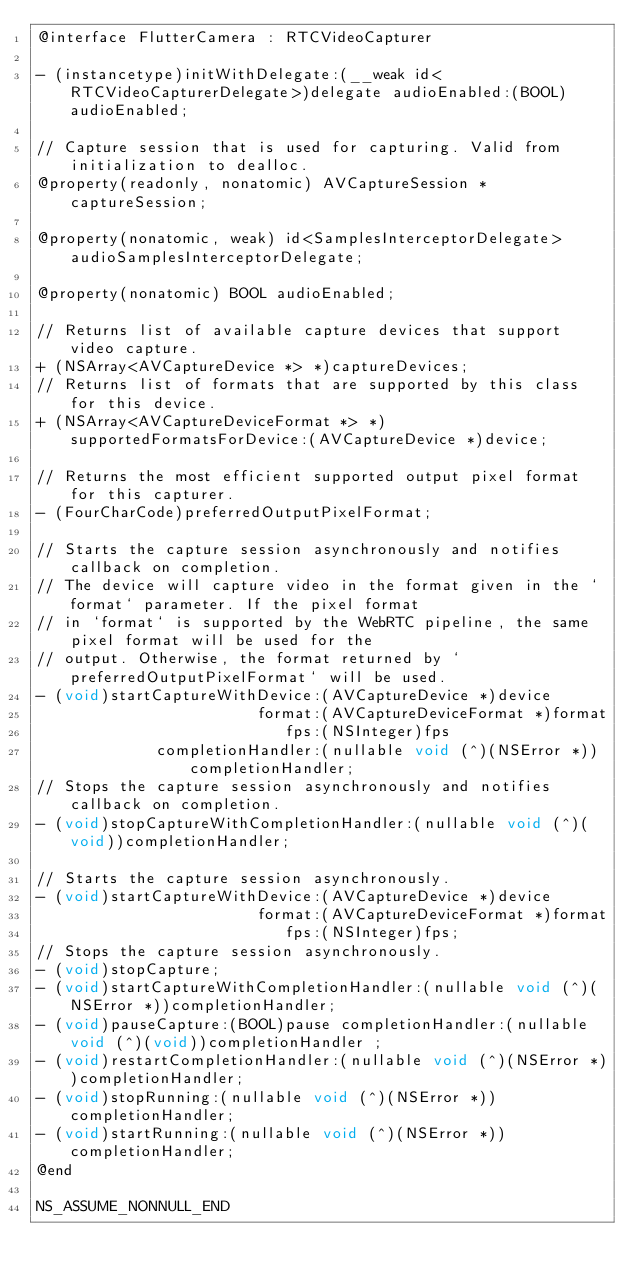Convert code to text. <code><loc_0><loc_0><loc_500><loc_500><_C_>@interface FlutterCamera : RTCVideoCapturer

- (instancetype)initWithDelegate:(__weak id<RTCVideoCapturerDelegate>)delegate audioEnabled:(BOOL)audioEnabled;

// Capture session that is used for capturing. Valid from initialization to dealloc.
@property(readonly, nonatomic) AVCaptureSession *captureSession;

@property(nonatomic, weak) id<SamplesInterceptorDelegate> audioSamplesInterceptorDelegate;

@property(nonatomic) BOOL audioEnabled;

// Returns list of available capture devices that support video capture.
+ (NSArray<AVCaptureDevice *> *)captureDevices;
// Returns list of formats that are supported by this class for this device.
+ (NSArray<AVCaptureDeviceFormat *> *)supportedFormatsForDevice:(AVCaptureDevice *)device;

// Returns the most efficient supported output pixel format for this capturer.
- (FourCharCode)preferredOutputPixelFormat;

// Starts the capture session asynchronously and notifies callback on completion.
// The device will capture video in the format given in the `format` parameter. If the pixel format
// in `format` is supported by the WebRTC pipeline, the same pixel format will be used for the
// output. Otherwise, the format returned by `preferredOutputPixelFormat` will be used.
- (void)startCaptureWithDevice:(AVCaptureDevice *)device
                        format:(AVCaptureDeviceFormat *)format
                           fps:(NSInteger)fps
             completionHandler:(nullable void (^)(NSError *))completionHandler;
// Stops the capture session asynchronously and notifies callback on completion.
- (void)stopCaptureWithCompletionHandler:(nullable void (^)(void))completionHandler;

// Starts the capture session asynchronously.
- (void)startCaptureWithDevice:(AVCaptureDevice *)device
                        format:(AVCaptureDeviceFormat *)format
                           fps:(NSInteger)fps;
// Stops the capture session asynchronously.
- (void)stopCapture;
- (void)startCaptureWithCompletionHandler:(nullable void (^)(NSError *))completionHandler;
- (void)pauseCapture:(BOOL)pause completionHandler:(nullable void (^)(void))completionHandler ;
- (void)restartCompletionHandler:(nullable void (^)(NSError *))completionHandler;
- (void)stopRunning:(nullable void (^)(NSError *))completionHandler;
- (void)startRunning:(nullable void (^)(NSError *))completionHandler;
@end

NS_ASSUME_NONNULL_END

</code> 